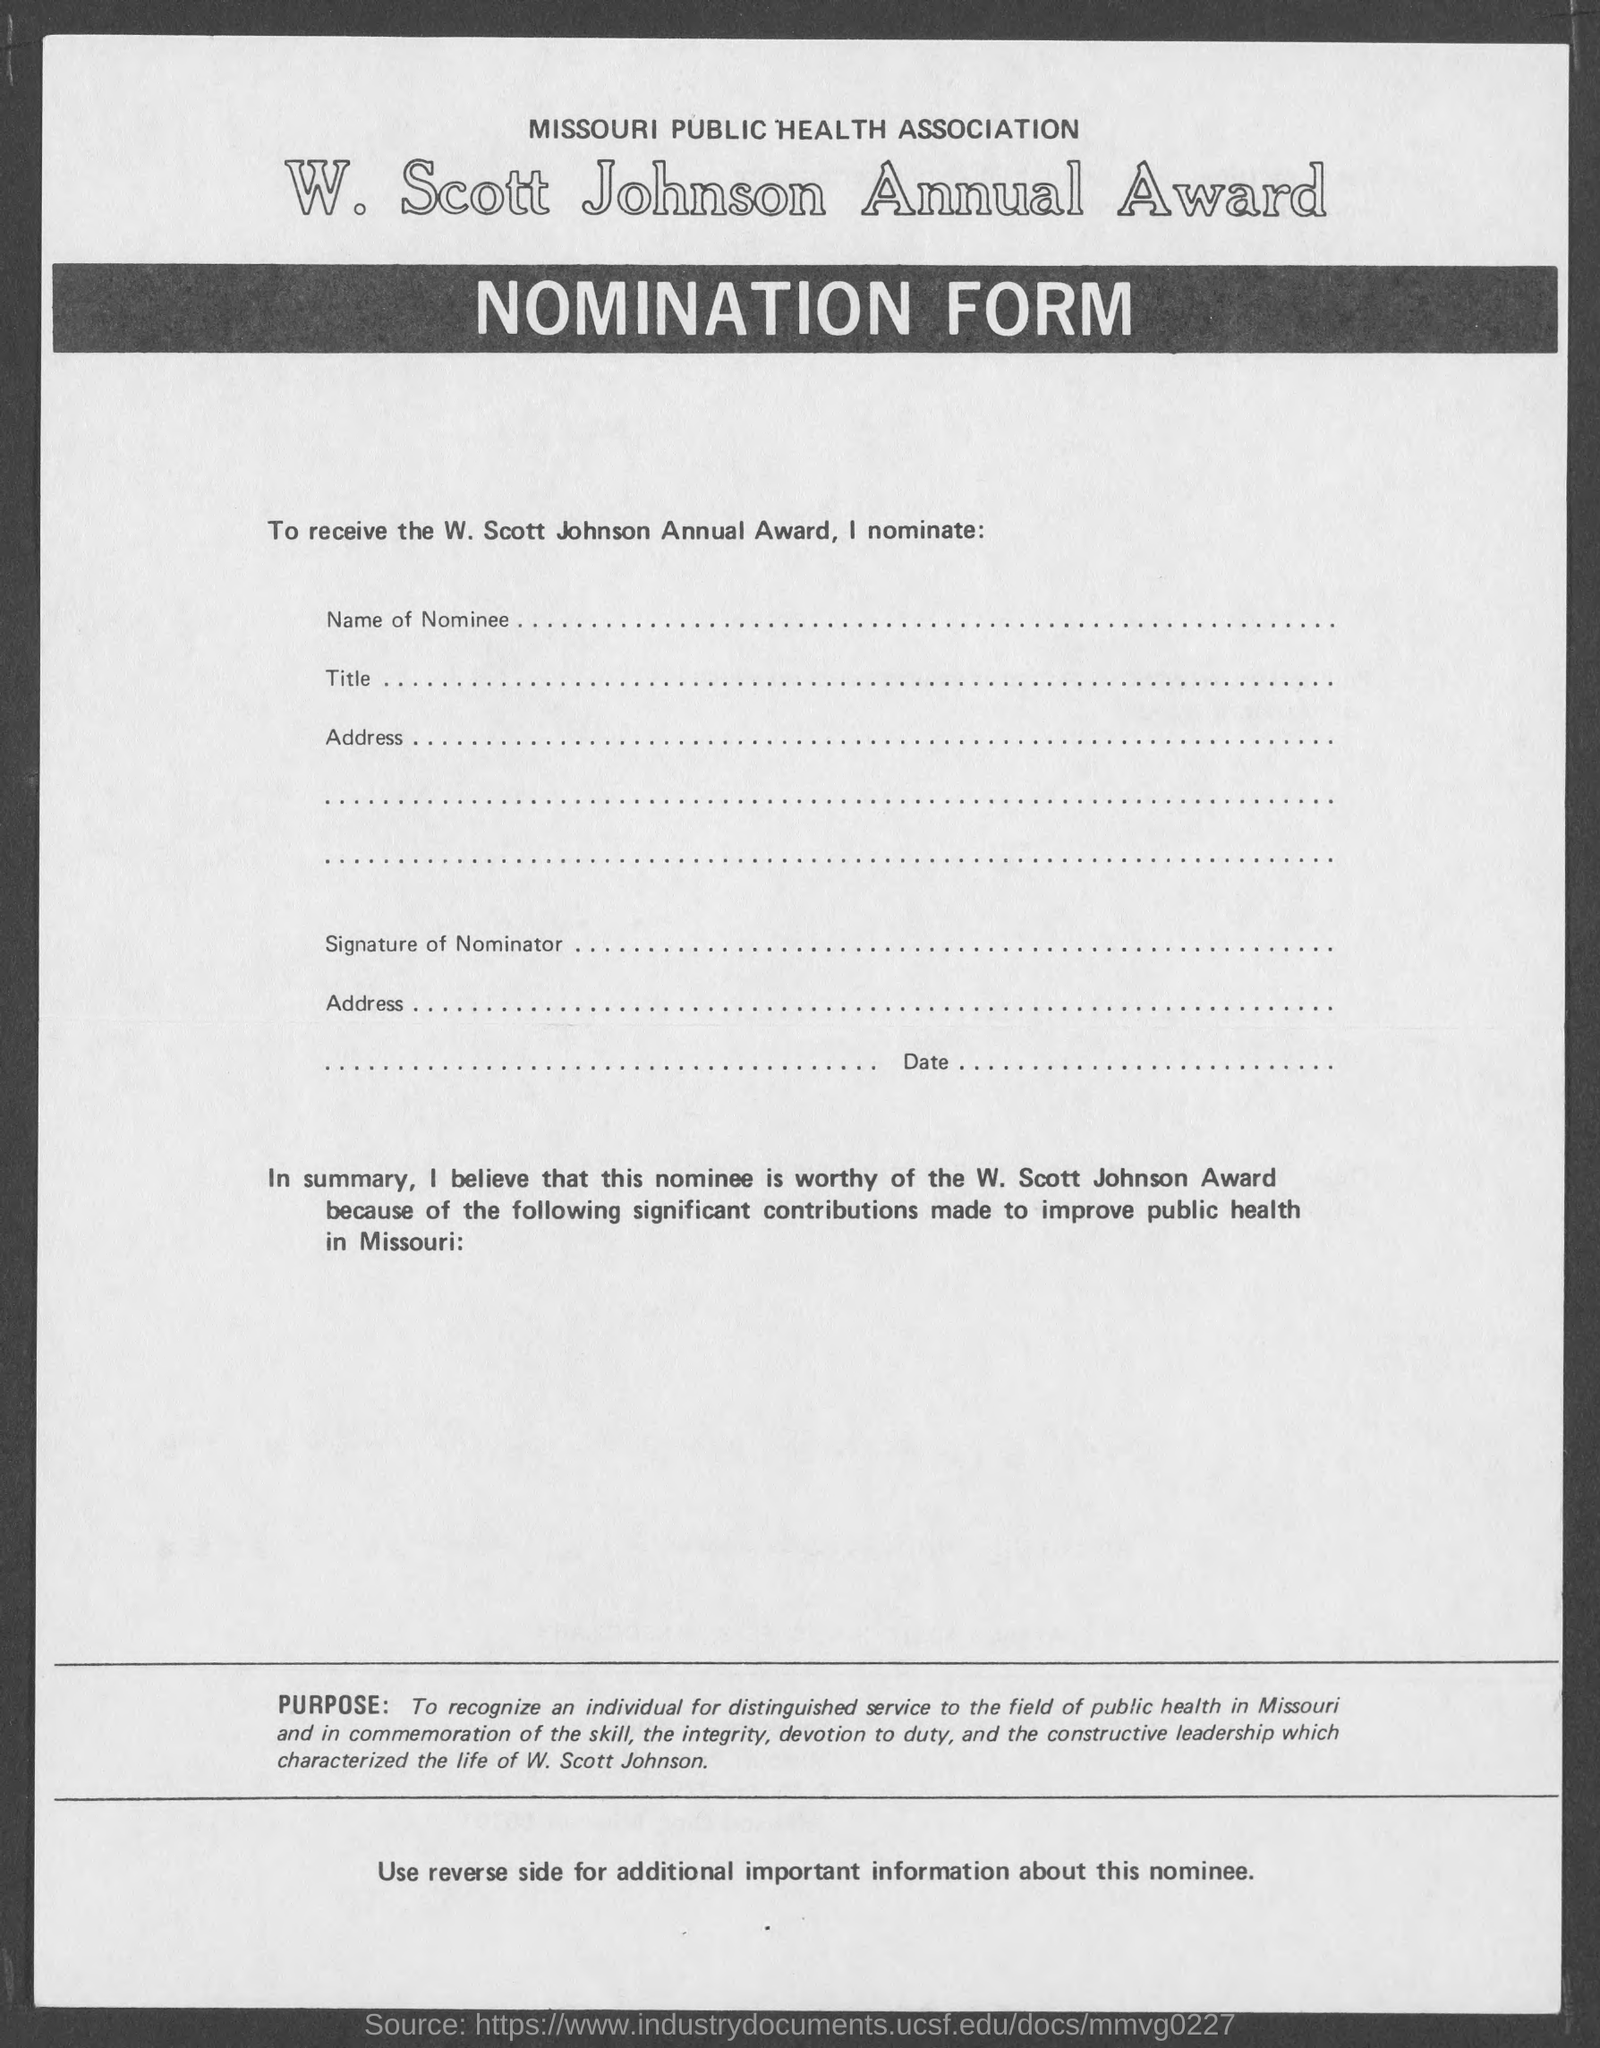What is the form about?
Your response must be concise. Nomination form. 